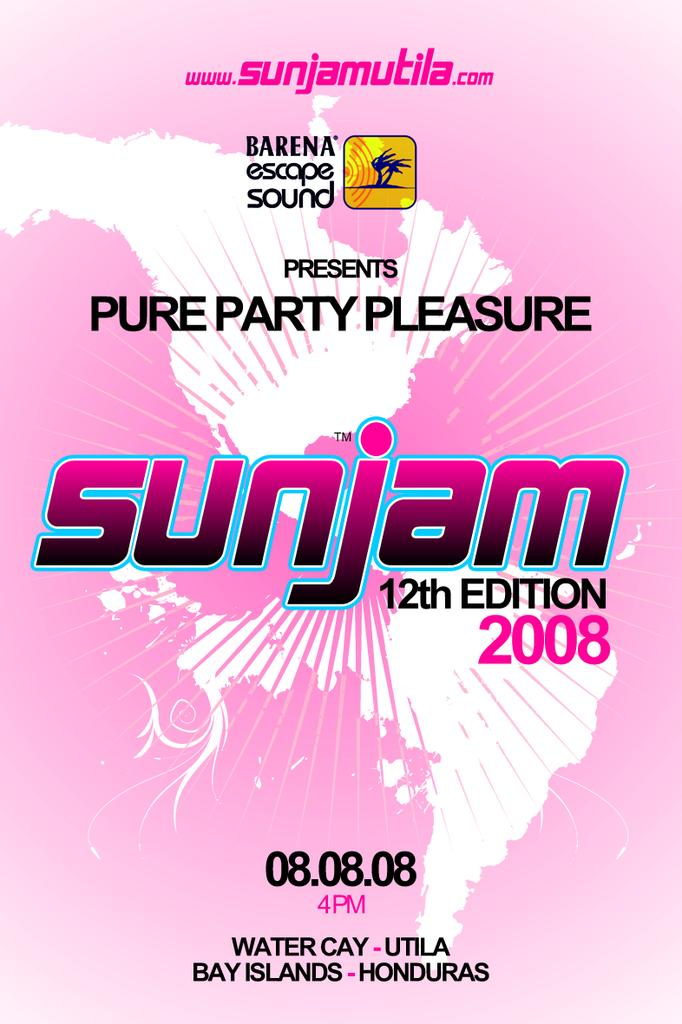<image>
Offer a succinct explanation of the picture presented. Barena Escape Sound presents Sunjam 12 edition on 08.08.08. 